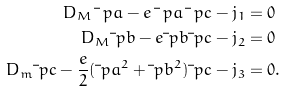Convert formula to latex. <formula><loc_0><loc_0><loc_500><loc_500>D _ { M } \bar { \ } p a - e \bar { \ } p a \bar { \ } p c - j _ { 1 } & = 0 \\ D _ { M } \bar { \ } p b - e \bar { \ } p b \bar { \ } p c - j _ { 2 } & = 0 \\ D _ { m } \bar { \ } p c - \frac { e } { 2 } ( \bar { \ } p a ^ { 2 } + \bar { \ } p b ^ { 2 } ) \bar { \ } p c - j _ { 3 } & = 0 .</formula> 